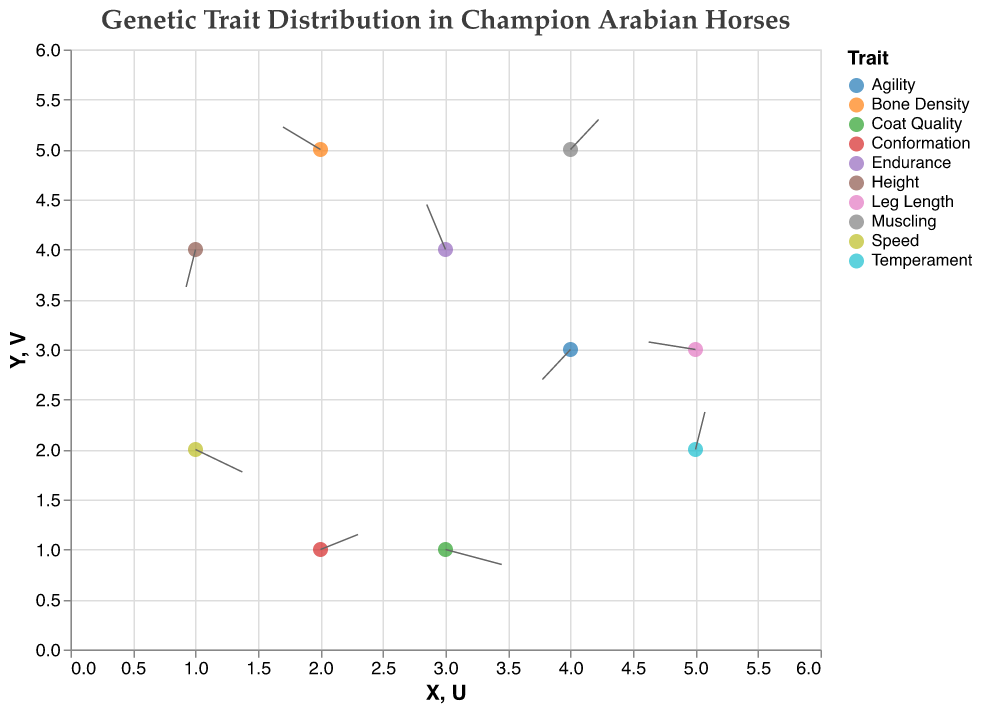What is the title of the figure? The title appears at the top of the figure and typically provides a concise description of what the figure is about. In this case, the title is "Genetic Trait Distribution in Champion Arabian Horses".
Answer: Genetic Trait Distribution in Champion Arabian Horses How many traits are displayed in the figure? Each unique trait is represented by a different point and color in the figure. By counting the number of unique trait names in the dataset, you can find that there are 10 different traits shown.
Answer: 10 Which trait is represented at the point (3,4)? To find the trait at this point, look for the pair (3, 4) in the X and Y columns of the dataset. The corresponding trait in that row is "Endurance".
Answer: Endurance Which trait shows the largest movement vector? The movement vector can be calculated as the Euclidean distance using U and V values. For each trait, calculate √(U² + V²). "Coat Quality" has the largest movement vector with U=0.6 and V=-0.2, resulting in √(0.6² + (-0.2)²) = √(0.36 + 0.04) = √0.4 ≈ 0.63.
Answer: Coat Quality Which trait's vector points upward (positive V value)? Traits with a positive V value have vectors pointing upward. From the dataset, these traits are "Endurance", "Temperament", "Bone Density", "Muscling", and "Leg Length".
Answer: Endurance, Temperament, Bone Density, Muscling, Leg Length Is there any trait with no horizontal (U) or vertical (V) movement? If U or V is zero, the trait has no movement in that direction. In the dataset, no trait has both U and V equal to zero.
Answer: No What is the overall direction of the 'Speed' trait vector? The 'Speed' trait vector has U=0.5 and V=-0.3. A positive U value means it moves to the right, and a negative V value means it moves downward.
Answer: Right and Downward Compare the traits 'Speed' and 'Coat Quality' in terms of horizontal (U) movement. Which has a greater positive U value? The 'Speed' trait has U=0.5, and 'Coat Quality' has U=0.6. Comparing these values, 'Coat Quality' has a greater positive U value.
Answer: Coat Quality Which trait is shown at the lowest Y coordinate in the figure? By examining the Y column, the trait at the lowest Y coordinate is 'Conformation', located at Y=1.
Answer: Conformation 